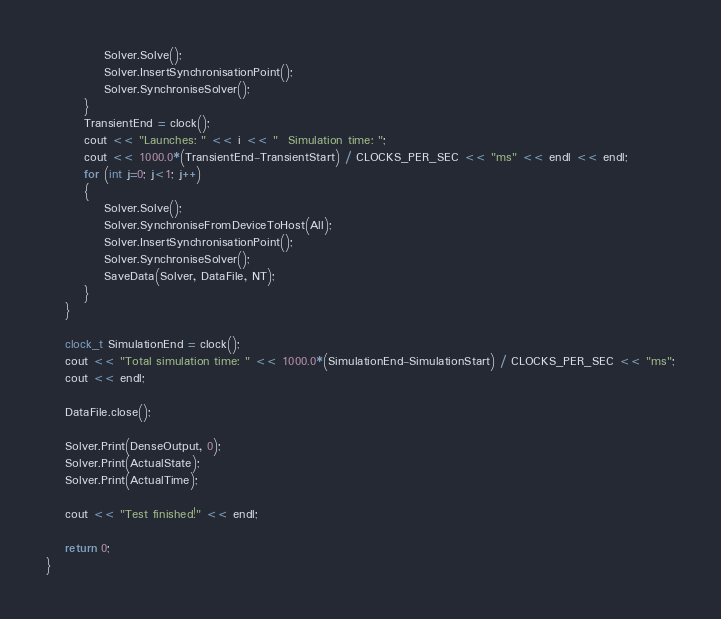Convert code to text. <code><loc_0><loc_0><loc_500><loc_500><_Cuda_>            Solver.Solve();
            Solver.InsertSynchronisationPoint();
            Solver.SynchroniseSolver();
        }
        TransientEnd = clock();
        cout << "Launches: " << i << "  Simulation time: ";
        cout << 1000.0*(TransientEnd-TransientStart) / CLOCKS_PER_SEC << "ms" << endl << endl;
        for (int j=0; j<1; j++)
        {
            Solver.Solve();
            Solver.SynchroniseFromDeviceToHost(All);
            Solver.InsertSynchronisationPoint();
            Solver.SynchroniseSolver();
            SaveData(Solver, DataFile, NT);
        }
    }

    clock_t SimulationEnd = clock();
    cout << "Total simulation time: " << 1000.0*(SimulationEnd-SimulationStart) / CLOCKS_PER_SEC << "ms";
    cout << endl;
	
    DataFile.close();
    
    Solver.Print(DenseOutput, 0);
    Solver.Print(ActualState);
    Solver.Print(ActualTime);
	
    cout << "Test finished!" << endl;

    return 0;
}

</code> 